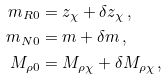<formula> <loc_0><loc_0><loc_500><loc_500>m _ { R 0 } & = z _ { \chi } + \delta z _ { \chi } \, , \\ m _ { N 0 } & = m + \delta m \, , \\ M _ { \rho 0 } & = M _ { \rho \chi } + \delta M _ { \rho \chi } \, ,</formula> 